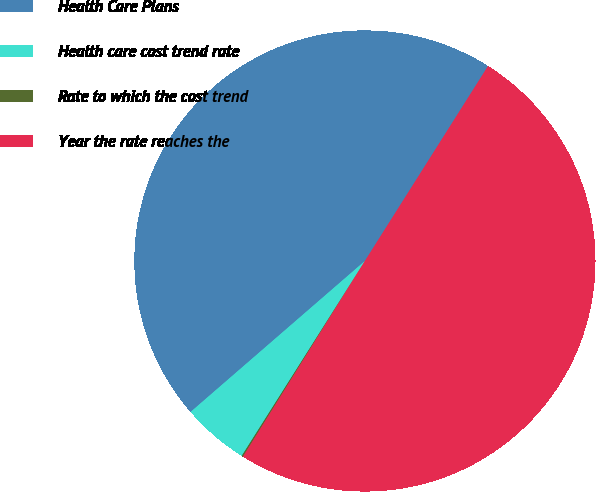Convert chart to OTSL. <chart><loc_0><loc_0><loc_500><loc_500><pie_chart><fcel>Health Care Plans<fcel>Health care cost trend rate<fcel>Rate to which the cost trend<fcel>Year the rate reaches the<nl><fcel>45.33%<fcel>4.67%<fcel>0.1%<fcel>49.9%<nl></chart> 